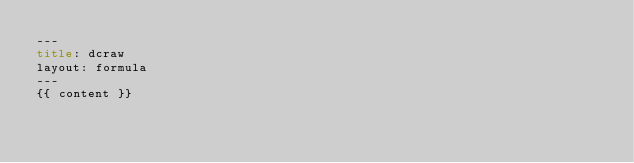Convert code to text. <code><loc_0><loc_0><loc_500><loc_500><_HTML_>---
title: dcraw
layout: formula
---
{{ content }}
</code> 